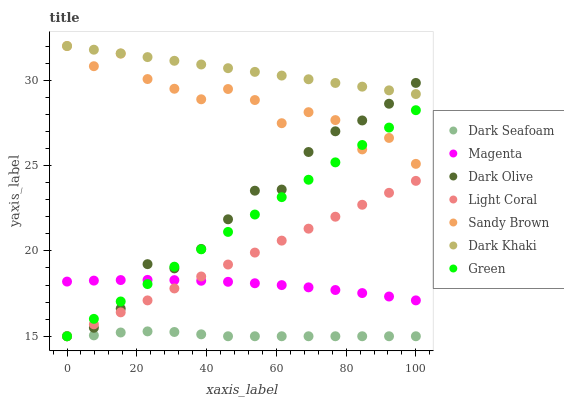Does Dark Seafoam have the minimum area under the curve?
Answer yes or no. Yes. Does Dark Khaki have the maximum area under the curve?
Answer yes or no. Yes. Does Dark Olive have the minimum area under the curve?
Answer yes or no. No. Does Dark Olive have the maximum area under the curve?
Answer yes or no. No. Is Dark Khaki the smoothest?
Answer yes or no. Yes. Is Sandy Brown the roughest?
Answer yes or no. Yes. Is Dark Olive the smoothest?
Answer yes or no. No. Is Dark Olive the roughest?
Answer yes or no. No. Does Dark Olive have the lowest value?
Answer yes or no. Yes. Does Magenta have the lowest value?
Answer yes or no. No. Does Sandy Brown have the highest value?
Answer yes or no. Yes. Does Dark Olive have the highest value?
Answer yes or no. No. Is Light Coral less than Dark Khaki?
Answer yes or no. Yes. Is Sandy Brown greater than Magenta?
Answer yes or no. Yes. Does Dark Olive intersect Green?
Answer yes or no. Yes. Is Dark Olive less than Green?
Answer yes or no. No. Is Dark Olive greater than Green?
Answer yes or no. No. Does Light Coral intersect Dark Khaki?
Answer yes or no. No. 